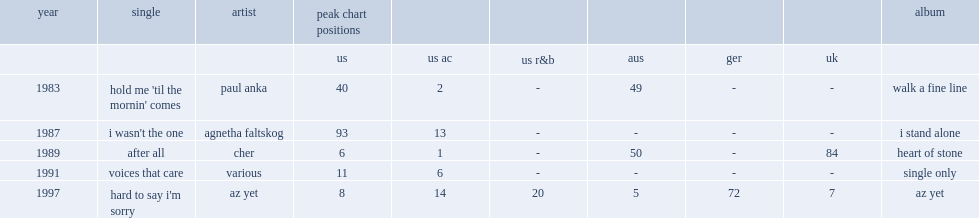In 1989, which album did cetera record a song with cher called "after all" of ? Heart of stone. 